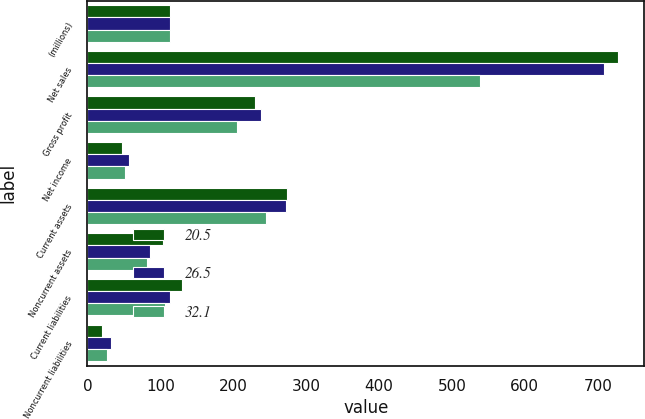<chart> <loc_0><loc_0><loc_500><loc_500><stacked_bar_chart><ecel><fcel>(millions)<fcel>Net sales<fcel>Gross profit<fcel>Net income<fcel>Current assets<fcel>Noncurrent assets<fcel>Current liabilities<fcel>Noncurrent liabilities<nl><fcel>20.5<fcel>113.2<fcel>727.1<fcel>229.2<fcel>47.1<fcel>274.4<fcel>104.2<fcel>129.9<fcel>20.5<nl><fcel>26.5<fcel>113.2<fcel>708.5<fcel>238.7<fcel>57.2<fcel>272<fcel>86.5<fcel>113.2<fcel>32.1<nl><fcel>32.1<fcel>113.2<fcel>538.3<fcel>205.2<fcel>51.6<fcel>245.2<fcel>81.5<fcel>105.9<fcel>26.5<nl></chart> 